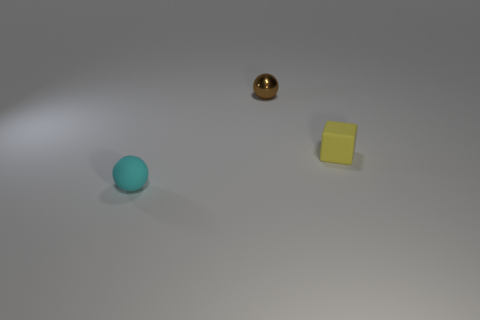What color is the other object that is the same shape as the cyan matte object?
Your answer should be compact. Brown. The thing that is left of the small yellow matte cube and in front of the brown object has what shape?
Keep it short and to the point. Sphere. Is the number of small brown shiny objects greater than the number of tiny spheres?
Provide a short and direct response. No. What material is the brown thing?
Keep it short and to the point. Metal. Are there any objects that are to the right of the thing in front of the yellow matte thing?
Your response must be concise. Yes. What number of other things are there of the same shape as the small yellow object?
Offer a terse response. 0. Are there more tiny balls left of the tiny brown sphere than small cubes on the left side of the small yellow matte block?
Offer a terse response. Yes. There is a ball that is in front of the shiny object; does it have the same size as the object that is behind the tiny yellow thing?
Offer a very short reply. Yes. The tiny yellow object has what shape?
Offer a terse response. Cube. What is the color of the ball that is the same material as the block?
Your response must be concise. Cyan. 